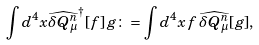<formula> <loc_0><loc_0><loc_500><loc_500>\int d ^ { 4 } x \widehat { \delta Q ^ { n } _ { \mu } } ^ { \dagger } [ f ] \, g \colon = \int d ^ { 4 } x \, f \, \widehat { \delta Q ^ { n } _ { \mu } } [ g ] ,</formula> 